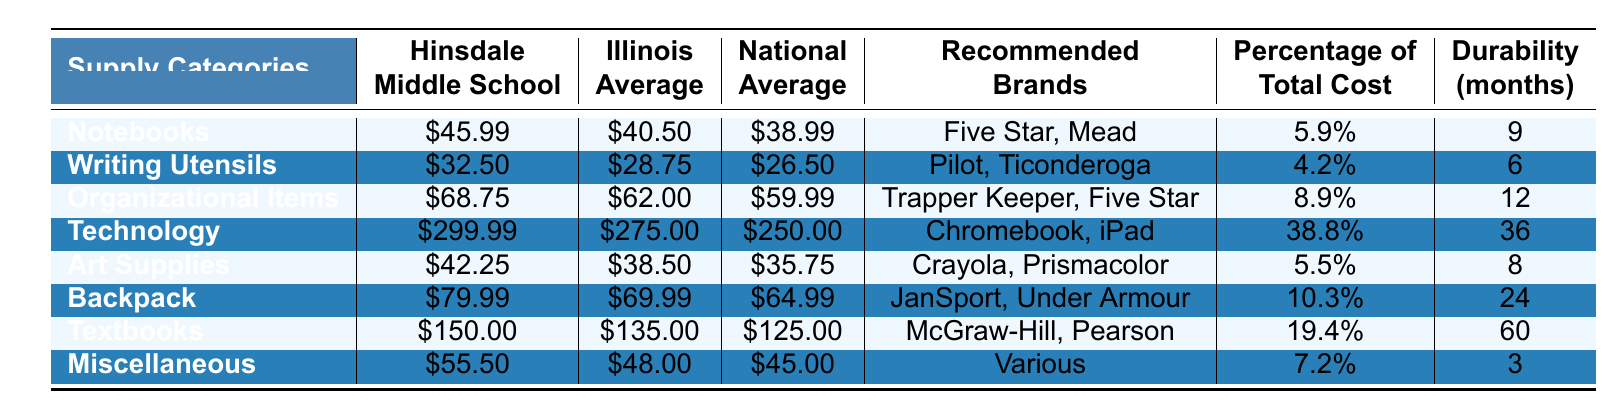What is the total cost for Technology supplies at Hinsdale Middle School? The table shows that the cost for Technology supplies at Hinsdale Middle School is \$299.99.
Answer: \$299.99 Which supply category has the highest percentage of total cost? The Technology category has the highest percentage of total cost at 38.8%, compared to other categories listed in the table.
Answer: Technology How much more does Hinsdale Middle School spend on Textbooks than the Illinois average? Hinsdale Middle School spends \$150.00 on Textbooks while the Illinois average is \$135.00. The difference is \$150.00 - \$135.00 = \$15.00.
Answer: \$15.00 What is the durability period (in months) of Organizational Items? The table lists the durability of Organizational Items as 12 months.
Answer: 12 months Is the cost for Art Supplies at Hinsdale Middle School higher than the National Average? The cost for Art Supplies at Hinsdale Middle School is \$42.25, while the National Average is \$35.75. Since \$42.25 > \$35.75, it is higher.
Answer: Yes What is the average cost of supplies (excluding Technology) at Hinsdale Middle School? The costs excluding Technology are \$45.99, \$32.50, \$68.75, \$42.25, \$79.99, \$150.00, and \$55.50. Their sum is \$45.99 + \$32.50 + \$68.75 + \$42.25 + \$79.99 + \$150.00 + \$55.50 = \$474.98. There are 7 categories, so the average is \$474.98 / 7 ≈ \$67.85.
Answer: Approximately \$67.85 What is the difference between the total costs for Notebooks at Hinsdale Middle School and the Illinois Average? Hinsdale Middle School spends \$45.99 on Notebooks, while the Illinois Average is \$40.50. The difference is \$45.99 - \$40.50 = \$5.49.
Answer: \$5.49 How much do Writing Utensils cost on average among all three levels (Hinsdale, Illinois, National)? The costs for Writing Utensils are \$32.50 (Hinsdale), \$28.75 (Illinois), and \$26.50 (National). The average is (\$32.50 + \$28.75 + \$26.50) / 3 = \$87.75 / 3 ≈ \$29.25.
Answer: Approximately \$29.25 Which supply category has the lowest cost in Hinsdale Middle School? The supply category with the lowest cost at Hinsdale Middle School is Writing Utensils at \$32.50.
Answer: Writing Utensils What percentage of total cost do Miscellaneous supplies represent at Hinsdale Middle School? Miscellaneous supplies represent 7.2% of the total cost at Hinsdale Middle School according to the table.
Answer: 7.2% 